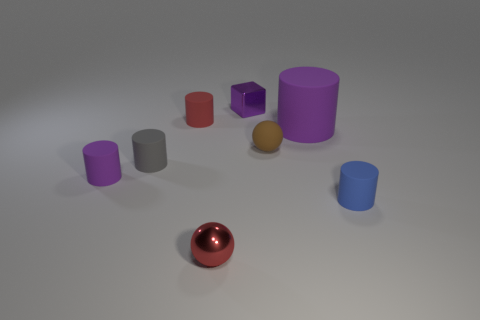Subtract all blue cylinders. How many cylinders are left? 4 Subtract all gray cylinders. How many cylinders are left? 4 Subtract all yellow cylinders. Subtract all green balls. How many cylinders are left? 5 Add 1 large blue matte cylinders. How many objects exist? 9 Subtract all cubes. How many objects are left? 7 Add 7 gray matte objects. How many gray matte objects are left? 8 Add 7 green rubber objects. How many green rubber objects exist? 7 Subtract 0 gray blocks. How many objects are left? 8 Subtract all small things. Subtract all yellow balls. How many objects are left? 1 